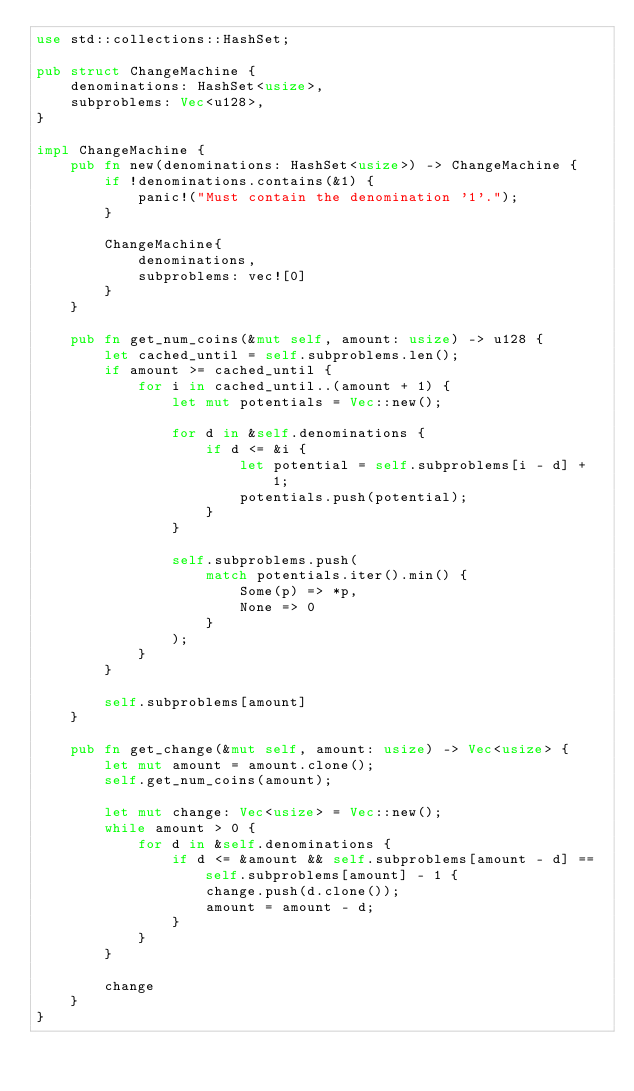Convert code to text. <code><loc_0><loc_0><loc_500><loc_500><_Rust_>use std::collections::HashSet;

pub struct ChangeMachine {
    denominations: HashSet<usize>,
    subproblems: Vec<u128>,
}

impl ChangeMachine {
    pub fn new(denominations: HashSet<usize>) -> ChangeMachine {
        if !denominations.contains(&1) {
            panic!("Must contain the denomination '1'.");
        }

        ChangeMachine{
            denominations,
            subproblems: vec![0]
        }
    }

    pub fn get_num_coins(&mut self, amount: usize) -> u128 {
        let cached_until = self.subproblems.len();
        if amount >= cached_until {
            for i in cached_until..(amount + 1) {
                let mut potentials = Vec::new();

                for d in &self.denominations {
                    if d <= &i {
                        let potential = self.subproblems[i - d] + 1;
                        potentials.push(potential);
                    }
                }

                self.subproblems.push(
                    match potentials.iter().min() {
                        Some(p) => *p,
                        None => 0
                    }
                );
            }
        }

        self.subproblems[amount]
    }

    pub fn get_change(&mut self, amount: usize) -> Vec<usize> {
        let mut amount = amount.clone();
        self.get_num_coins(amount);

        let mut change: Vec<usize> = Vec::new();
        while amount > 0 {
            for d in &self.denominations {
                if d <= &amount && self.subproblems[amount - d] == self.subproblems[amount] - 1 {
                    change.push(d.clone());
                    amount = amount - d;
                }
            }
        }

        change
    }
}

</code> 